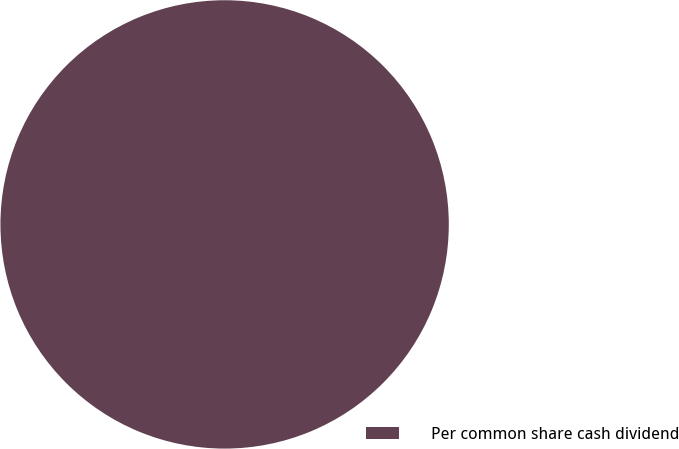Convert chart to OTSL. <chart><loc_0><loc_0><loc_500><loc_500><pie_chart><fcel>Per common share cash dividend<nl><fcel>100.0%<nl></chart> 